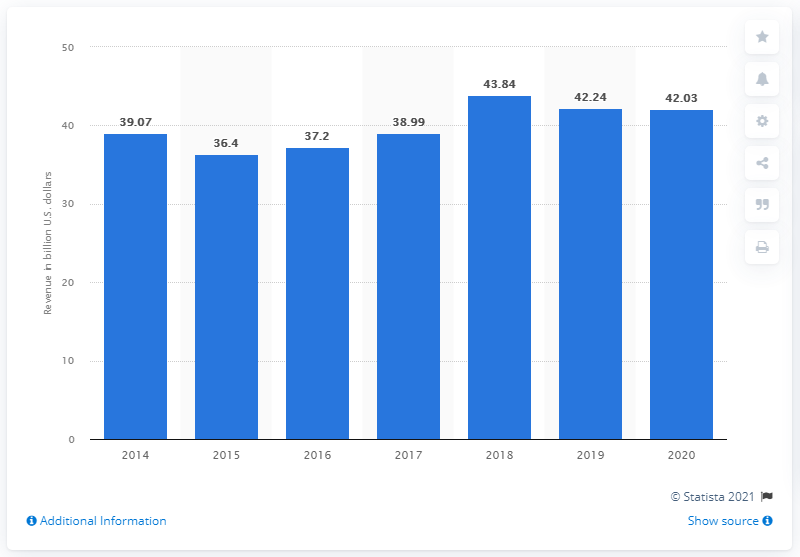Give some essential details in this illustration. MetLife's revenue from premiums in 2020 was $42,030,000. 